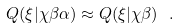Convert formula to latex. <formula><loc_0><loc_0><loc_500><loc_500>Q ( \xi | \chi \beta \alpha ) \approx Q ( \xi | \chi \beta ) \ .</formula> 